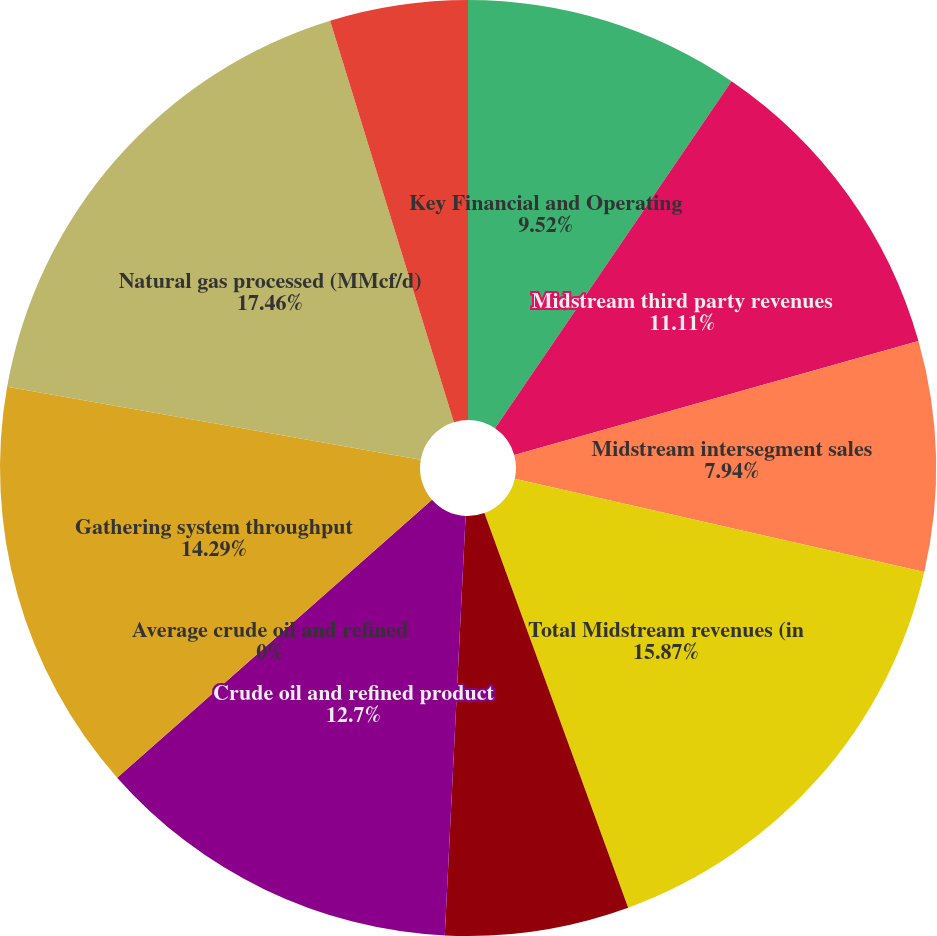Convert chart. <chart><loc_0><loc_0><loc_500><loc_500><pie_chart><fcel>Key Financial and Operating<fcel>Midstream third party revenues<fcel>Midstream intersegment sales<fcel>Total Midstream revenues (in<fcel>Midstream income from<fcel>Crude oil and refined product<fcel>Average crude oil and refined<fcel>Gathering system throughput<fcel>Natural gas processed (MMcf/d)<fcel>C2 (ethane) + NGLs<nl><fcel>9.52%<fcel>11.11%<fcel>7.94%<fcel>15.87%<fcel>6.35%<fcel>12.7%<fcel>0.0%<fcel>14.29%<fcel>17.46%<fcel>4.76%<nl></chart> 